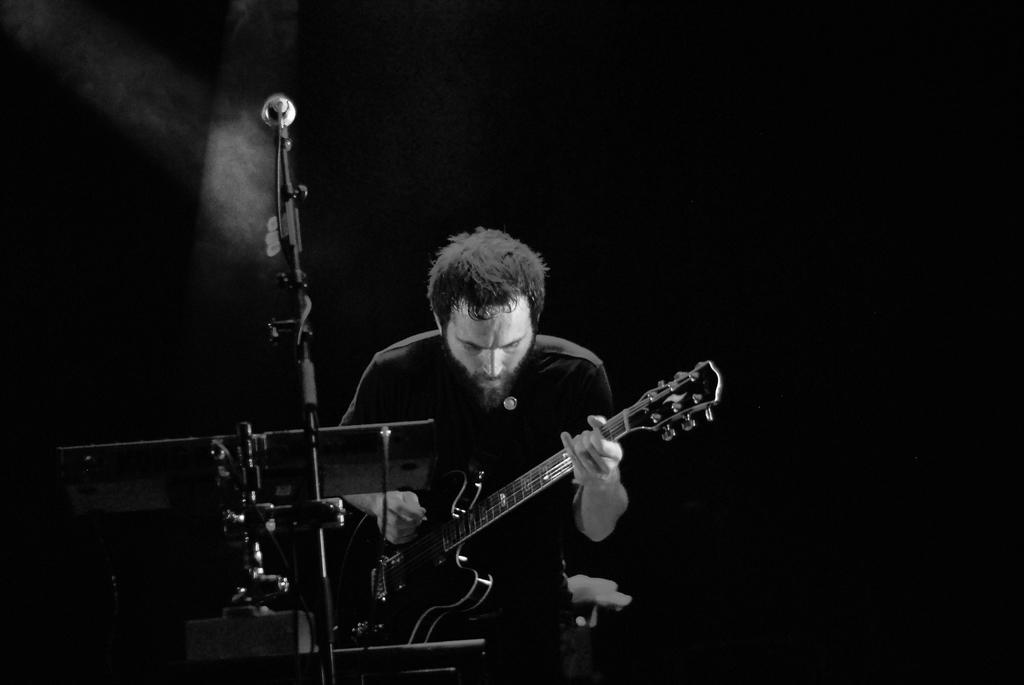What is the person in the image doing? The person in the image is playing a guitar. What is in front of the person? There is a stand, a wire, and a microphone in front of the person. Can you describe the stand in front of the person? The stand is likely a music stand or a microphone stand, but the specific type is not mentioned in the facts. What is the purpose of the wire in front of the person? The purpose of the wire is not specified in the facts, but it could be a guitar cable or a microphone cable. What is the name of the goldfish swimming in the image? There is no goldfish present in the image; it features a person playing a guitar with a stand, wire, and microphone in front of them. 